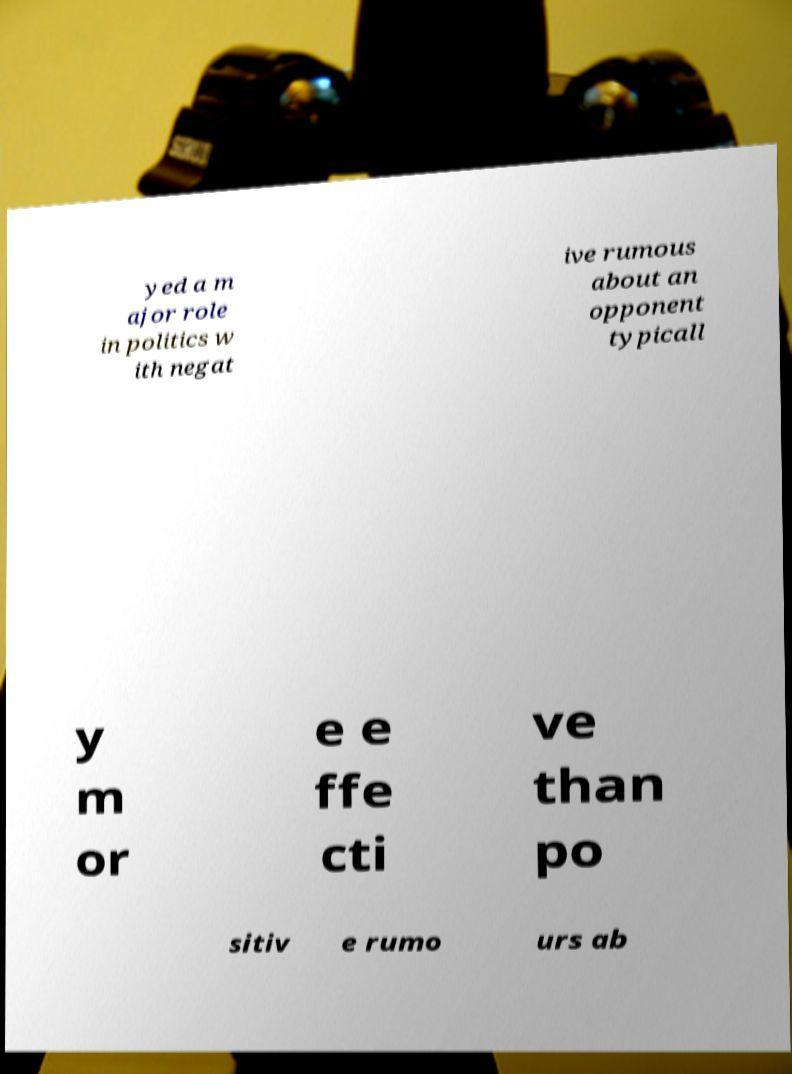Can you read and provide the text displayed in the image?This photo seems to have some interesting text. Can you extract and type it out for me? yed a m ajor role in politics w ith negat ive rumous about an opponent typicall y m or e e ffe cti ve than po sitiv e rumo urs ab 